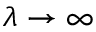Convert formula to latex. <formula><loc_0><loc_0><loc_500><loc_500>\lambda \to \infty</formula> 